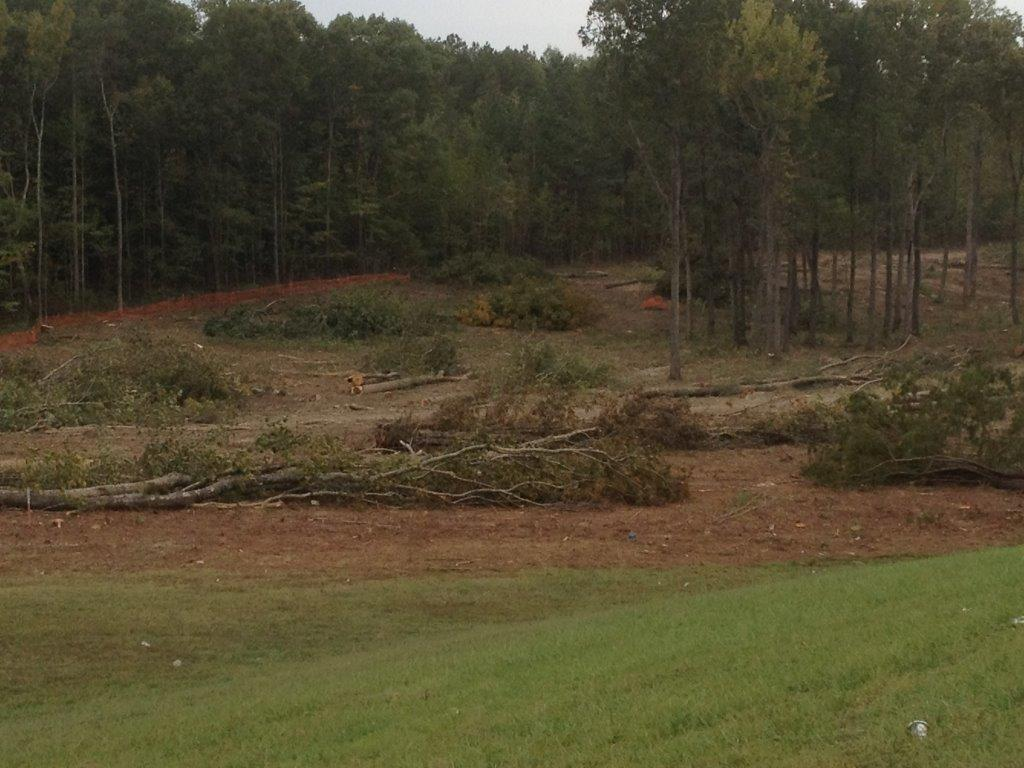What can be seen in the center of the image? The sky is visible in the center of the image. What type of vegetation is present in the image? There are trees and plants in the image. What is the ground made of in the image? Grass and soil are visible in the image. How many weeks can be seen in the image? There are no weeks visible in the image, as weeks are a unit of time and not a physical object that can be seen. 